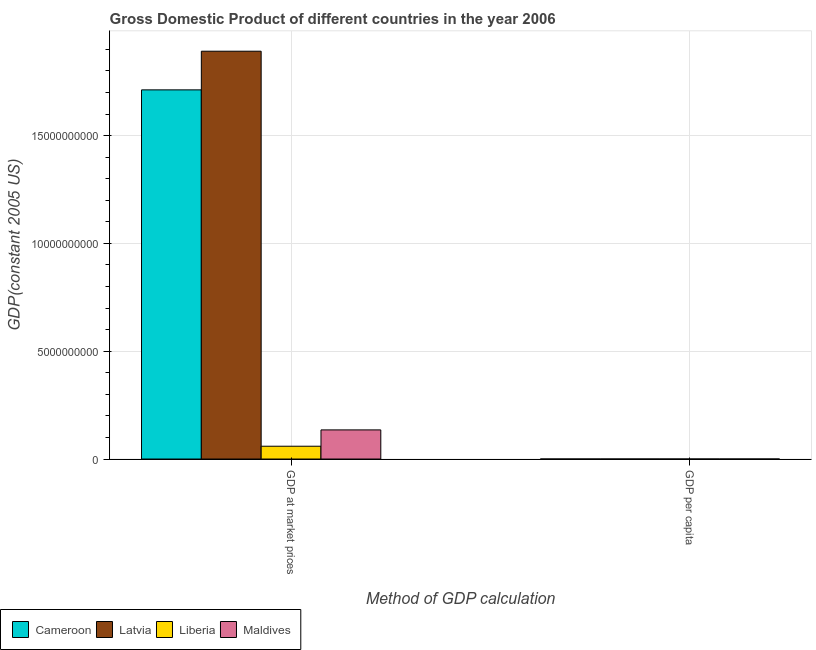Are the number of bars on each tick of the X-axis equal?
Your answer should be very brief. Yes. What is the label of the 1st group of bars from the left?
Keep it short and to the point. GDP at market prices. What is the gdp at market prices in Maldives?
Your answer should be very brief. 1.35e+09. Across all countries, what is the maximum gdp at market prices?
Your response must be concise. 1.89e+1. Across all countries, what is the minimum gdp per capita?
Give a very brief answer. 175.56. In which country was the gdp per capita maximum?
Provide a succinct answer. Latvia. In which country was the gdp per capita minimum?
Make the answer very short. Liberia. What is the total gdp at market prices in the graph?
Give a very brief answer. 3.80e+1. What is the difference between the gdp per capita in Cameroon and that in Latvia?
Provide a short and direct response. -7605.91. What is the difference between the gdp per capita in Latvia and the gdp at market prices in Cameroon?
Provide a succinct answer. -1.71e+1. What is the average gdp per capita per country?
Give a very brief answer. 3420.06. What is the difference between the gdp per capita and gdp at market prices in Cameroon?
Your response must be concise. -1.71e+1. In how many countries, is the gdp at market prices greater than 17000000000 US$?
Provide a short and direct response. 2. What is the ratio of the gdp per capita in Liberia to that in Latvia?
Your answer should be very brief. 0.02. In how many countries, is the gdp at market prices greater than the average gdp at market prices taken over all countries?
Provide a short and direct response. 2. What does the 2nd bar from the left in GDP per capita represents?
Your answer should be very brief. Latvia. What does the 3rd bar from the right in GDP at market prices represents?
Provide a succinct answer. Latvia. Are all the bars in the graph horizontal?
Your answer should be very brief. No. Are the values on the major ticks of Y-axis written in scientific E-notation?
Keep it short and to the point. No. Where does the legend appear in the graph?
Your response must be concise. Bottom left. How are the legend labels stacked?
Your answer should be very brief. Horizontal. What is the title of the graph?
Your answer should be very brief. Gross Domestic Product of different countries in the year 2006. What is the label or title of the X-axis?
Ensure brevity in your answer.  Method of GDP calculation. What is the label or title of the Y-axis?
Provide a short and direct response. GDP(constant 2005 US). What is the GDP(constant 2005 US) in Cameroon in GDP at market prices?
Offer a terse response. 1.71e+1. What is the GDP(constant 2005 US) of Latvia in GDP at market prices?
Provide a short and direct response. 1.89e+1. What is the GDP(constant 2005 US) in Liberia in GDP at market prices?
Offer a terse response. 5.94e+08. What is the GDP(constant 2005 US) in Maldives in GDP at market prices?
Keep it short and to the point. 1.35e+09. What is the GDP(constant 2005 US) of Cameroon in GDP per capita?
Offer a terse response. 920.72. What is the GDP(constant 2005 US) in Latvia in GDP per capita?
Keep it short and to the point. 8526.63. What is the GDP(constant 2005 US) in Liberia in GDP per capita?
Your response must be concise. 175.56. What is the GDP(constant 2005 US) in Maldives in GDP per capita?
Ensure brevity in your answer.  4057.34. Across all Method of GDP calculation, what is the maximum GDP(constant 2005 US) of Cameroon?
Offer a terse response. 1.71e+1. Across all Method of GDP calculation, what is the maximum GDP(constant 2005 US) of Latvia?
Make the answer very short. 1.89e+1. Across all Method of GDP calculation, what is the maximum GDP(constant 2005 US) of Liberia?
Provide a succinct answer. 5.94e+08. Across all Method of GDP calculation, what is the maximum GDP(constant 2005 US) in Maldives?
Ensure brevity in your answer.  1.35e+09. Across all Method of GDP calculation, what is the minimum GDP(constant 2005 US) of Cameroon?
Your answer should be very brief. 920.72. Across all Method of GDP calculation, what is the minimum GDP(constant 2005 US) of Latvia?
Your answer should be compact. 8526.63. Across all Method of GDP calculation, what is the minimum GDP(constant 2005 US) of Liberia?
Your answer should be compact. 175.56. Across all Method of GDP calculation, what is the minimum GDP(constant 2005 US) in Maldives?
Your answer should be compact. 4057.34. What is the total GDP(constant 2005 US) in Cameroon in the graph?
Your answer should be compact. 1.71e+1. What is the total GDP(constant 2005 US) in Latvia in the graph?
Your response must be concise. 1.89e+1. What is the total GDP(constant 2005 US) of Liberia in the graph?
Keep it short and to the point. 5.94e+08. What is the total GDP(constant 2005 US) of Maldives in the graph?
Keep it short and to the point. 1.35e+09. What is the difference between the GDP(constant 2005 US) of Cameroon in GDP at market prices and that in GDP per capita?
Keep it short and to the point. 1.71e+1. What is the difference between the GDP(constant 2005 US) of Latvia in GDP at market prices and that in GDP per capita?
Offer a very short reply. 1.89e+1. What is the difference between the GDP(constant 2005 US) of Liberia in GDP at market prices and that in GDP per capita?
Provide a succinct answer. 5.94e+08. What is the difference between the GDP(constant 2005 US) of Maldives in GDP at market prices and that in GDP per capita?
Ensure brevity in your answer.  1.35e+09. What is the difference between the GDP(constant 2005 US) of Cameroon in GDP at market prices and the GDP(constant 2005 US) of Latvia in GDP per capita?
Provide a succinct answer. 1.71e+1. What is the difference between the GDP(constant 2005 US) in Cameroon in GDP at market prices and the GDP(constant 2005 US) in Liberia in GDP per capita?
Your answer should be very brief. 1.71e+1. What is the difference between the GDP(constant 2005 US) of Cameroon in GDP at market prices and the GDP(constant 2005 US) of Maldives in GDP per capita?
Your response must be concise. 1.71e+1. What is the difference between the GDP(constant 2005 US) in Latvia in GDP at market prices and the GDP(constant 2005 US) in Liberia in GDP per capita?
Ensure brevity in your answer.  1.89e+1. What is the difference between the GDP(constant 2005 US) of Latvia in GDP at market prices and the GDP(constant 2005 US) of Maldives in GDP per capita?
Your answer should be very brief. 1.89e+1. What is the difference between the GDP(constant 2005 US) in Liberia in GDP at market prices and the GDP(constant 2005 US) in Maldives in GDP per capita?
Ensure brevity in your answer.  5.94e+08. What is the average GDP(constant 2005 US) of Cameroon per Method of GDP calculation?
Provide a short and direct response. 8.56e+09. What is the average GDP(constant 2005 US) of Latvia per Method of GDP calculation?
Your response must be concise. 9.46e+09. What is the average GDP(constant 2005 US) in Liberia per Method of GDP calculation?
Ensure brevity in your answer.  2.97e+08. What is the average GDP(constant 2005 US) of Maldives per Method of GDP calculation?
Provide a short and direct response. 6.76e+08. What is the difference between the GDP(constant 2005 US) of Cameroon and GDP(constant 2005 US) of Latvia in GDP at market prices?
Offer a very short reply. -1.79e+09. What is the difference between the GDP(constant 2005 US) in Cameroon and GDP(constant 2005 US) in Liberia in GDP at market prices?
Provide a succinct answer. 1.65e+1. What is the difference between the GDP(constant 2005 US) in Cameroon and GDP(constant 2005 US) in Maldives in GDP at market prices?
Offer a terse response. 1.58e+1. What is the difference between the GDP(constant 2005 US) in Latvia and GDP(constant 2005 US) in Liberia in GDP at market prices?
Your answer should be very brief. 1.83e+1. What is the difference between the GDP(constant 2005 US) of Latvia and GDP(constant 2005 US) of Maldives in GDP at market prices?
Make the answer very short. 1.76e+1. What is the difference between the GDP(constant 2005 US) in Liberia and GDP(constant 2005 US) in Maldives in GDP at market prices?
Give a very brief answer. -7.57e+08. What is the difference between the GDP(constant 2005 US) in Cameroon and GDP(constant 2005 US) in Latvia in GDP per capita?
Keep it short and to the point. -7605.91. What is the difference between the GDP(constant 2005 US) in Cameroon and GDP(constant 2005 US) in Liberia in GDP per capita?
Ensure brevity in your answer.  745.16. What is the difference between the GDP(constant 2005 US) in Cameroon and GDP(constant 2005 US) in Maldives in GDP per capita?
Provide a succinct answer. -3136.63. What is the difference between the GDP(constant 2005 US) of Latvia and GDP(constant 2005 US) of Liberia in GDP per capita?
Give a very brief answer. 8351.07. What is the difference between the GDP(constant 2005 US) of Latvia and GDP(constant 2005 US) of Maldives in GDP per capita?
Provide a succinct answer. 4469.29. What is the difference between the GDP(constant 2005 US) of Liberia and GDP(constant 2005 US) of Maldives in GDP per capita?
Keep it short and to the point. -3881.78. What is the ratio of the GDP(constant 2005 US) in Cameroon in GDP at market prices to that in GDP per capita?
Your answer should be compact. 1.86e+07. What is the ratio of the GDP(constant 2005 US) in Latvia in GDP at market prices to that in GDP per capita?
Provide a short and direct response. 2.22e+06. What is the ratio of the GDP(constant 2005 US) in Liberia in GDP at market prices to that in GDP per capita?
Your answer should be very brief. 3.38e+06. What is the ratio of the GDP(constant 2005 US) of Maldives in GDP at market prices to that in GDP per capita?
Your answer should be compact. 3.33e+05. What is the difference between the highest and the second highest GDP(constant 2005 US) in Cameroon?
Give a very brief answer. 1.71e+1. What is the difference between the highest and the second highest GDP(constant 2005 US) in Latvia?
Your answer should be very brief. 1.89e+1. What is the difference between the highest and the second highest GDP(constant 2005 US) in Liberia?
Your response must be concise. 5.94e+08. What is the difference between the highest and the second highest GDP(constant 2005 US) of Maldives?
Offer a very short reply. 1.35e+09. What is the difference between the highest and the lowest GDP(constant 2005 US) in Cameroon?
Provide a short and direct response. 1.71e+1. What is the difference between the highest and the lowest GDP(constant 2005 US) in Latvia?
Your answer should be very brief. 1.89e+1. What is the difference between the highest and the lowest GDP(constant 2005 US) in Liberia?
Give a very brief answer. 5.94e+08. What is the difference between the highest and the lowest GDP(constant 2005 US) of Maldives?
Offer a terse response. 1.35e+09. 